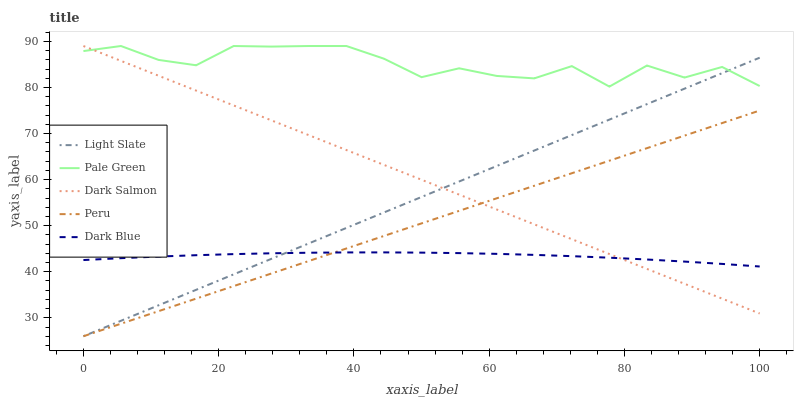Does Dark Blue have the minimum area under the curve?
Answer yes or no. Yes. Does Pale Green have the maximum area under the curve?
Answer yes or no. Yes. Does Pale Green have the minimum area under the curve?
Answer yes or no. No. Does Dark Blue have the maximum area under the curve?
Answer yes or no. No. Is Peru the smoothest?
Answer yes or no. Yes. Is Pale Green the roughest?
Answer yes or no. Yes. Is Dark Blue the smoothest?
Answer yes or no. No. Is Dark Blue the roughest?
Answer yes or no. No. Does Light Slate have the lowest value?
Answer yes or no. Yes. Does Dark Blue have the lowest value?
Answer yes or no. No. Does Dark Salmon have the highest value?
Answer yes or no. Yes. Does Dark Blue have the highest value?
Answer yes or no. No. Is Dark Blue less than Pale Green?
Answer yes or no. Yes. Is Pale Green greater than Peru?
Answer yes or no. Yes. Does Peru intersect Dark Blue?
Answer yes or no. Yes. Is Peru less than Dark Blue?
Answer yes or no. No. Is Peru greater than Dark Blue?
Answer yes or no. No. Does Dark Blue intersect Pale Green?
Answer yes or no. No. 